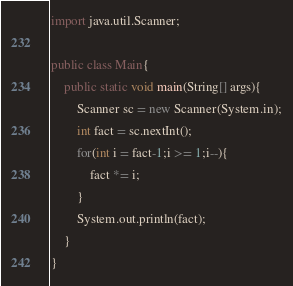Convert code to text. <code><loc_0><loc_0><loc_500><loc_500><_Java_>import java.util.Scanner;

public class Main{
	public static void main(String[] args){
		Scanner sc = new Scanner(System.in);
		int fact = sc.nextInt();
		for(int i = fact-1;i >= 1;i--){
			fact *= i;
		}
		System.out.println(fact);
    }
}</code> 